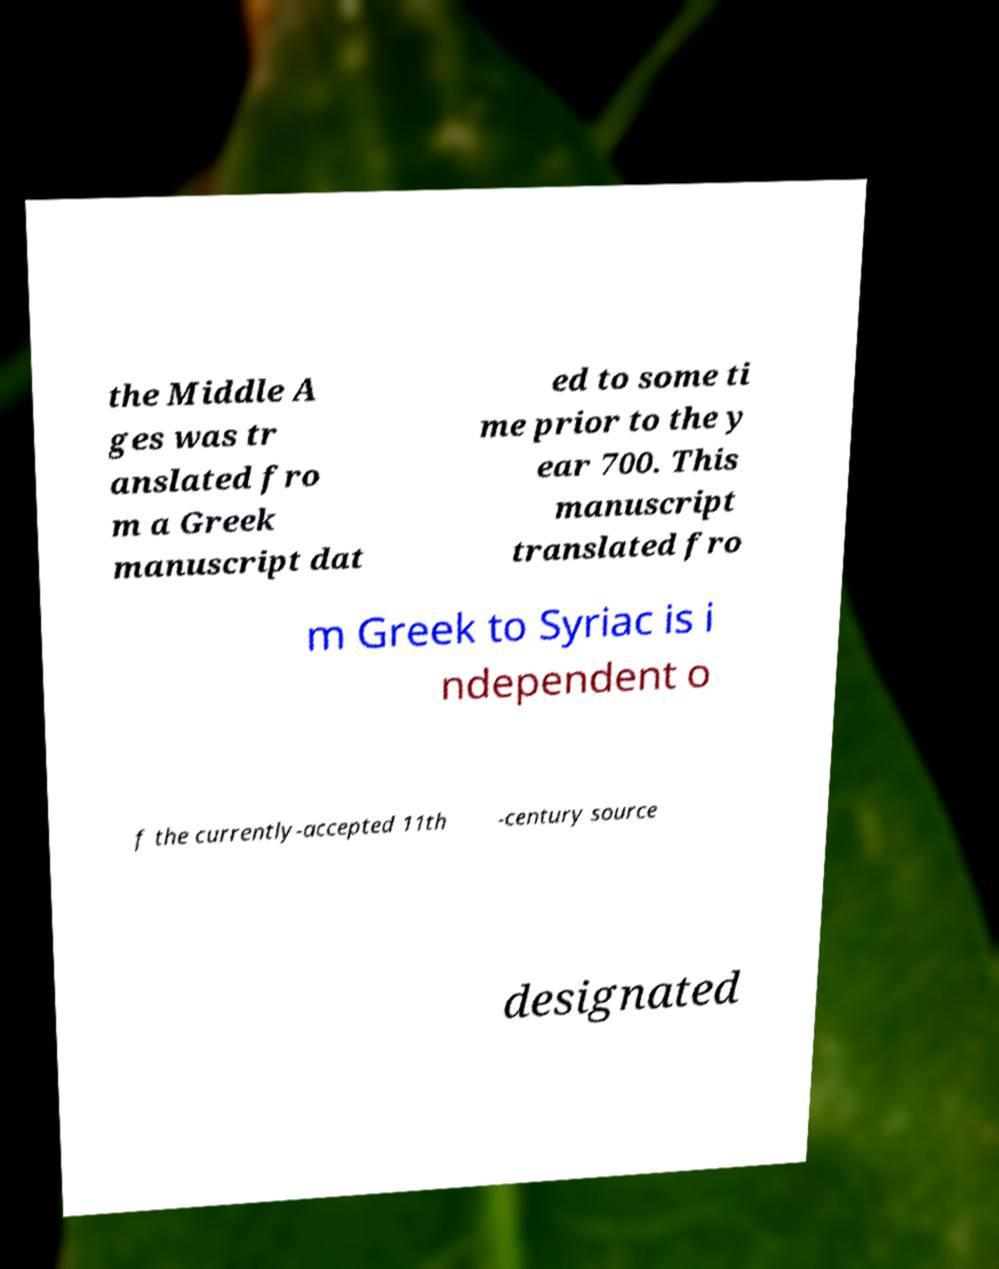There's text embedded in this image that I need extracted. Can you transcribe it verbatim? the Middle A ges was tr anslated fro m a Greek manuscript dat ed to some ti me prior to the y ear 700. This manuscript translated fro m Greek to Syriac is i ndependent o f the currently-accepted 11th -century source designated 